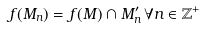<formula> <loc_0><loc_0><loc_500><loc_500>f ( M _ { n } ) = f ( M ) \cap M ^ { \prime } _ { n } \, \forall n \in \mathbb { Z } ^ { + }</formula> 